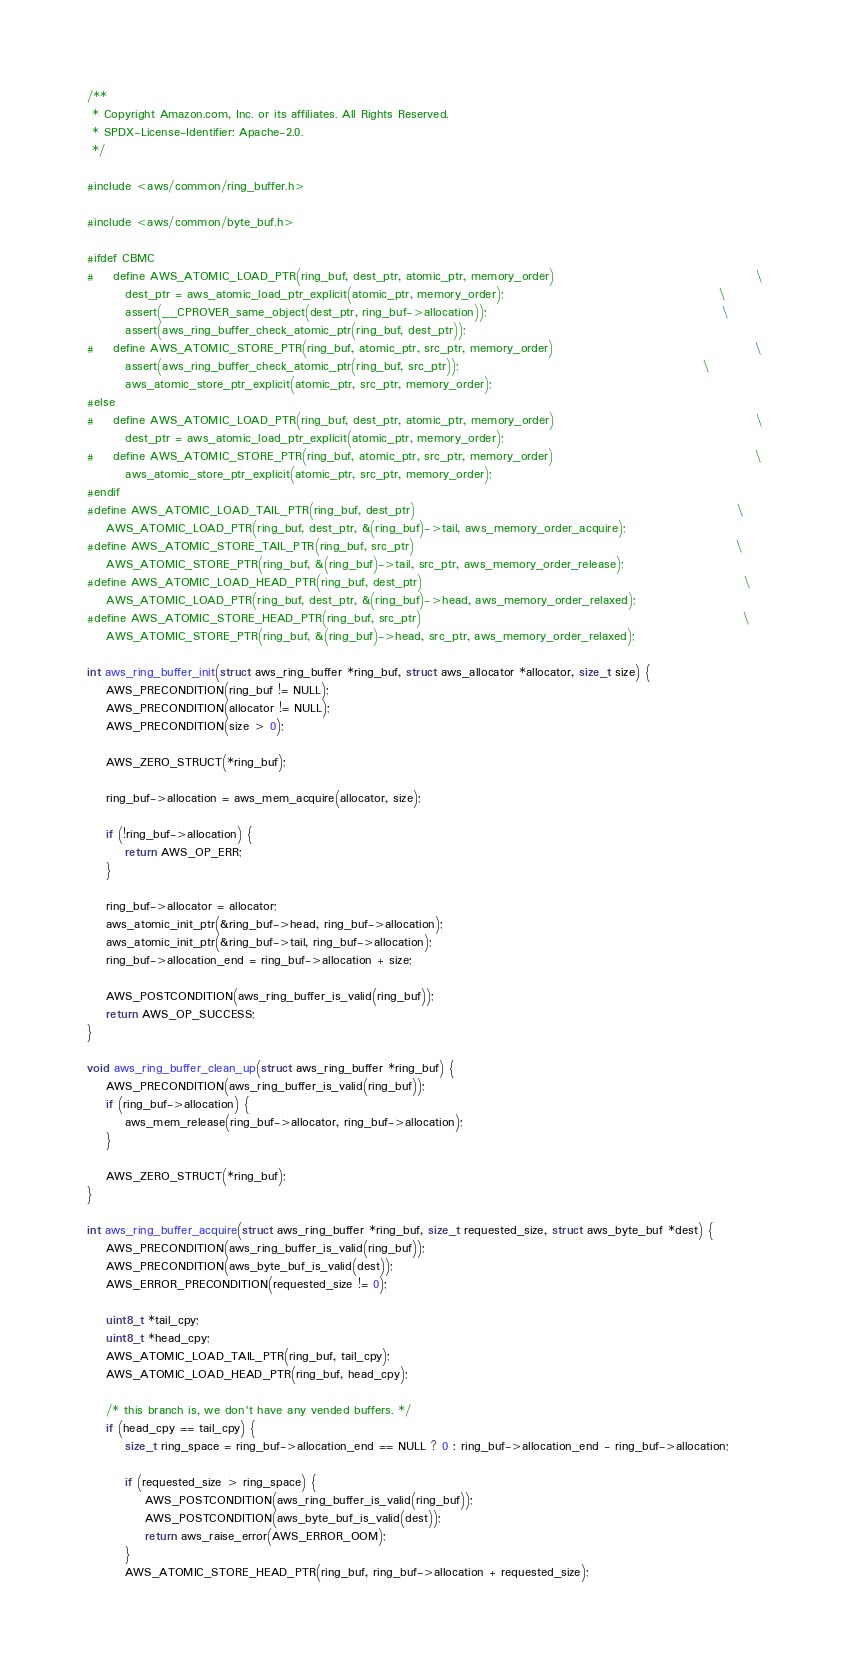Convert code to text. <code><loc_0><loc_0><loc_500><loc_500><_C_>/**
 * Copyright Amazon.com, Inc. or its affiliates. All Rights Reserved.
 * SPDX-License-Identifier: Apache-2.0.
 */

#include <aws/common/ring_buffer.h>

#include <aws/common/byte_buf.h>

#ifdef CBMC
#    define AWS_ATOMIC_LOAD_PTR(ring_buf, dest_ptr, atomic_ptr, memory_order)                                          \
        dest_ptr = aws_atomic_load_ptr_explicit(atomic_ptr, memory_order);                                             \
        assert(__CPROVER_same_object(dest_ptr, ring_buf->allocation));                                                 \
        assert(aws_ring_buffer_check_atomic_ptr(ring_buf, dest_ptr));
#    define AWS_ATOMIC_STORE_PTR(ring_buf, atomic_ptr, src_ptr, memory_order)                                          \
        assert(aws_ring_buffer_check_atomic_ptr(ring_buf, src_ptr));                                                   \
        aws_atomic_store_ptr_explicit(atomic_ptr, src_ptr, memory_order);
#else
#    define AWS_ATOMIC_LOAD_PTR(ring_buf, dest_ptr, atomic_ptr, memory_order)                                          \
        dest_ptr = aws_atomic_load_ptr_explicit(atomic_ptr, memory_order);
#    define AWS_ATOMIC_STORE_PTR(ring_buf, atomic_ptr, src_ptr, memory_order)                                          \
        aws_atomic_store_ptr_explicit(atomic_ptr, src_ptr, memory_order);
#endif
#define AWS_ATOMIC_LOAD_TAIL_PTR(ring_buf, dest_ptr)                                                                   \
    AWS_ATOMIC_LOAD_PTR(ring_buf, dest_ptr, &(ring_buf)->tail, aws_memory_order_acquire);
#define AWS_ATOMIC_STORE_TAIL_PTR(ring_buf, src_ptr)                                                                   \
    AWS_ATOMIC_STORE_PTR(ring_buf, &(ring_buf)->tail, src_ptr, aws_memory_order_release);
#define AWS_ATOMIC_LOAD_HEAD_PTR(ring_buf, dest_ptr)                                                                   \
    AWS_ATOMIC_LOAD_PTR(ring_buf, dest_ptr, &(ring_buf)->head, aws_memory_order_relaxed);
#define AWS_ATOMIC_STORE_HEAD_PTR(ring_buf, src_ptr)                                                                   \
    AWS_ATOMIC_STORE_PTR(ring_buf, &(ring_buf)->head, src_ptr, aws_memory_order_relaxed);

int aws_ring_buffer_init(struct aws_ring_buffer *ring_buf, struct aws_allocator *allocator, size_t size) {
    AWS_PRECONDITION(ring_buf != NULL);
    AWS_PRECONDITION(allocator != NULL);
    AWS_PRECONDITION(size > 0);

    AWS_ZERO_STRUCT(*ring_buf);

    ring_buf->allocation = aws_mem_acquire(allocator, size);

    if (!ring_buf->allocation) {
        return AWS_OP_ERR;
    }

    ring_buf->allocator = allocator;
    aws_atomic_init_ptr(&ring_buf->head, ring_buf->allocation);
    aws_atomic_init_ptr(&ring_buf->tail, ring_buf->allocation);
    ring_buf->allocation_end = ring_buf->allocation + size;

    AWS_POSTCONDITION(aws_ring_buffer_is_valid(ring_buf));
    return AWS_OP_SUCCESS;
}

void aws_ring_buffer_clean_up(struct aws_ring_buffer *ring_buf) {
    AWS_PRECONDITION(aws_ring_buffer_is_valid(ring_buf));
    if (ring_buf->allocation) {
        aws_mem_release(ring_buf->allocator, ring_buf->allocation);
    }

    AWS_ZERO_STRUCT(*ring_buf);
}

int aws_ring_buffer_acquire(struct aws_ring_buffer *ring_buf, size_t requested_size, struct aws_byte_buf *dest) {
    AWS_PRECONDITION(aws_ring_buffer_is_valid(ring_buf));
    AWS_PRECONDITION(aws_byte_buf_is_valid(dest));
    AWS_ERROR_PRECONDITION(requested_size != 0);

    uint8_t *tail_cpy;
    uint8_t *head_cpy;
    AWS_ATOMIC_LOAD_TAIL_PTR(ring_buf, tail_cpy);
    AWS_ATOMIC_LOAD_HEAD_PTR(ring_buf, head_cpy);

    /* this branch is, we don't have any vended buffers. */
    if (head_cpy == tail_cpy) {
        size_t ring_space = ring_buf->allocation_end == NULL ? 0 : ring_buf->allocation_end - ring_buf->allocation;

        if (requested_size > ring_space) {
            AWS_POSTCONDITION(aws_ring_buffer_is_valid(ring_buf));
            AWS_POSTCONDITION(aws_byte_buf_is_valid(dest));
            return aws_raise_error(AWS_ERROR_OOM);
        }
        AWS_ATOMIC_STORE_HEAD_PTR(ring_buf, ring_buf->allocation + requested_size);</code> 